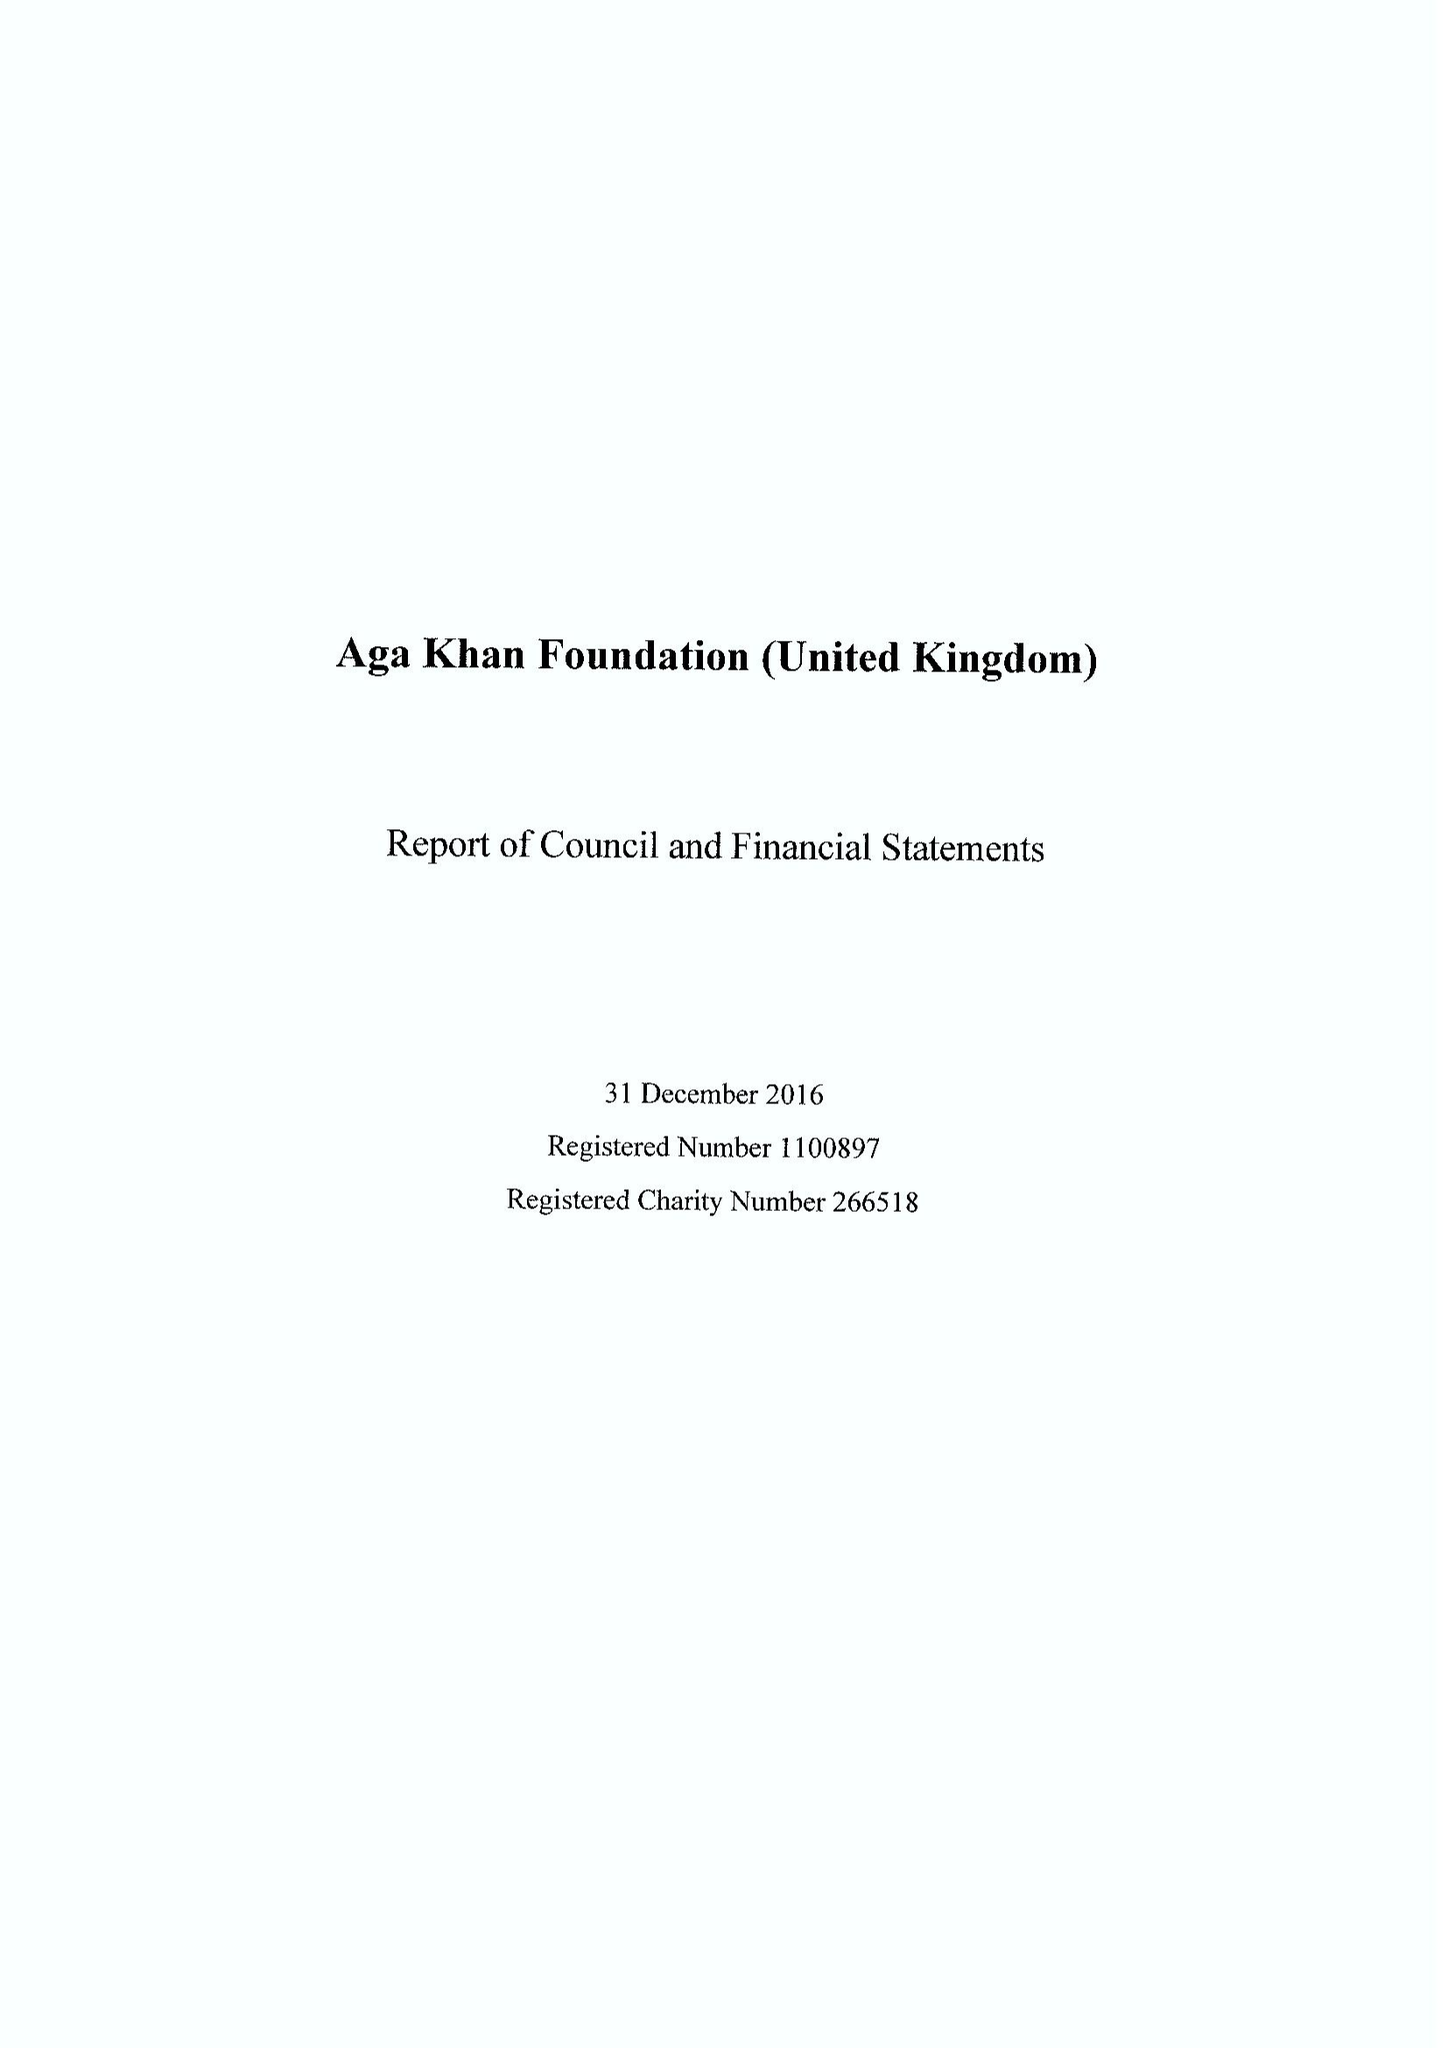What is the value for the charity_name?
Answer the question using a single word or phrase. Aga Khan Foundation (United Kingdom) 